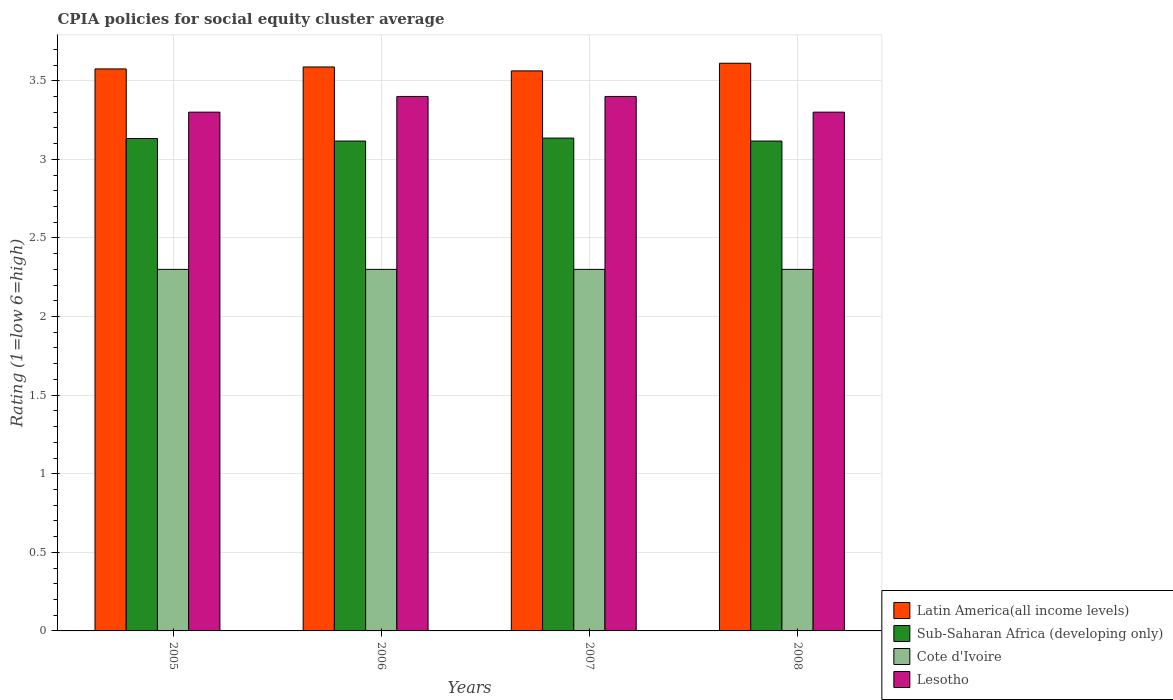How many groups of bars are there?
Offer a terse response. 4. Are the number of bars per tick equal to the number of legend labels?
Keep it short and to the point. Yes. What is the CPIA rating in Sub-Saharan Africa (developing only) in 2006?
Provide a succinct answer. 3.12. Across all years, what is the maximum CPIA rating in Sub-Saharan Africa (developing only)?
Give a very brief answer. 3.14. Across all years, what is the minimum CPIA rating in Lesotho?
Make the answer very short. 3.3. In which year was the CPIA rating in Sub-Saharan Africa (developing only) maximum?
Give a very brief answer. 2007. In which year was the CPIA rating in Sub-Saharan Africa (developing only) minimum?
Give a very brief answer. 2006. What is the total CPIA rating in Sub-Saharan Africa (developing only) in the graph?
Provide a short and direct response. 12.5. What is the difference between the CPIA rating in Sub-Saharan Africa (developing only) in 2006 and that in 2008?
Offer a terse response. 0. What is the difference between the CPIA rating in Sub-Saharan Africa (developing only) in 2007 and the CPIA rating in Lesotho in 2005?
Provide a short and direct response. -0.16. What is the average CPIA rating in Lesotho per year?
Give a very brief answer. 3.35. In the year 2008, what is the difference between the CPIA rating in Cote d'Ivoire and CPIA rating in Latin America(all income levels)?
Ensure brevity in your answer.  -1.31. What is the ratio of the CPIA rating in Cote d'Ivoire in 2005 to that in 2007?
Keep it short and to the point. 1. Is the difference between the CPIA rating in Cote d'Ivoire in 2007 and 2008 greater than the difference between the CPIA rating in Latin America(all income levels) in 2007 and 2008?
Provide a succinct answer. Yes. What is the difference between the highest and the second highest CPIA rating in Latin America(all income levels)?
Offer a terse response. 0.02. What is the difference between the highest and the lowest CPIA rating in Cote d'Ivoire?
Ensure brevity in your answer.  0. In how many years, is the CPIA rating in Cote d'Ivoire greater than the average CPIA rating in Cote d'Ivoire taken over all years?
Provide a succinct answer. 0. What does the 1st bar from the left in 2007 represents?
Your answer should be very brief. Latin America(all income levels). What does the 4th bar from the right in 2005 represents?
Provide a succinct answer. Latin America(all income levels). How many bars are there?
Your answer should be very brief. 16. How many years are there in the graph?
Provide a succinct answer. 4. What is the difference between two consecutive major ticks on the Y-axis?
Provide a short and direct response. 0.5. Does the graph contain any zero values?
Give a very brief answer. No. Does the graph contain grids?
Offer a very short reply. Yes. What is the title of the graph?
Provide a succinct answer. CPIA policies for social equity cluster average. Does "St. Vincent and the Grenadines" appear as one of the legend labels in the graph?
Keep it short and to the point. No. What is the label or title of the X-axis?
Offer a very short reply. Years. What is the label or title of the Y-axis?
Offer a very short reply. Rating (1=low 6=high). What is the Rating (1=low 6=high) of Latin America(all income levels) in 2005?
Your answer should be very brief. 3.58. What is the Rating (1=low 6=high) of Sub-Saharan Africa (developing only) in 2005?
Keep it short and to the point. 3.13. What is the Rating (1=low 6=high) in Latin America(all income levels) in 2006?
Your response must be concise. 3.59. What is the Rating (1=low 6=high) of Sub-Saharan Africa (developing only) in 2006?
Offer a terse response. 3.12. What is the Rating (1=low 6=high) of Latin America(all income levels) in 2007?
Your answer should be very brief. 3.56. What is the Rating (1=low 6=high) of Sub-Saharan Africa (developing only) in 2007?
Make the answer very short. 3.14. What is the Rating (1=low 6=high) in Cote d'Ivoire in 2007?
Your answer should be compact. 2.3. What is the Rating (1=low 6=high) of Latin America(all income levels) in 2008?
Provide a succinct answer. 3.61. What is the Rating (1=low 6=high) of Sub-Saharan Africa (developing only) in 2008?
Provide a short and direct response. 3.12. What is the Rating (1=low 6=high) of Lesotho in 2008?
Keep it short and to the point. 3.3. Across all years, what is the maximum Rating (1=low 6=high) in Latin America(all income levels)?
Your answer should be very brief. 3.61. Across all years, what is the maximum Rating (1=low 6=high) in Sub-Saharan Africa (developing only)?
Keep it short and to the point. 3.14. Across all years, what is the maximum Rating (1=low 6=high) of Cote d'Ivoire?
Keep it short and to the point. 2.3. Across all years, what is the minimum Rating (1=low 6=high) of Latin America(all income levels)?
Provide a short and direct response. 3.56. Across all years, what is the minimum Rating (1=low 6=high) in Sub-Saharan Africa (developing only)?
Ensure brevity in your answer.  3.12. Across all years, what is the minimum Rating (1=low 6=high) of Cote d'Ivoire?
Your answer should be compact. 2.3. Across all years, what is the minimum Rating (1=low 6=high) in Lesotho?
Give a very brief answer. 3.3. What is the total Rating (1=low 6=high) in Latin America(all income levels) in the graph?
Your response must be concise. 14.34. What is the total Rating (1=low 6=high) in Sub-Saharan Africa (developing only) in the graph?
Your answer should be very brief. 12.5. What is the total Rating (1=low 6=high) of Lesotho in the graph?
Provide a succinct answer. 13.4. What is the difference between the Rating (1=low 6=high) in Latin America(all income levels) in 2005 and that in 2006?
Ensure brevity in your answer.  -0.01. What is the difference between the Rating (1=low 6=high) of Sub-Saharan Africa (developing only) in 2005 and that in 2006?
Provide a short and direct response. 0.02. What is the difference between the Rating (1=low 6=high) in Cote d'Ivoire in 2005 and that in 2006?
Your answer should be compact. 0. What is the difference between the Rating (1=low 6=high) of Latin America(all income levels) in 2005 and that in 2007?
Provide a short and direct response. 0.01. What is the difference between the Rating (1=low 6=high) of Sub-Saharan Africa (developing only) in 2005 and that in 2007?
Provide a short and direct response. -0. What is the difference between the Rating (1=low 6=high) of Cote d'Ivoire in 2005 and that in 2007?
Make the answer very short. 0. What is the difference between the Rating (1=low 6=high) of Latin America(all income levels) in 2005 and that in 2008?
Ensure brevity in your answer.  -0.04. What is the difference between the Rating (1=low 6=high) in Sub-Saharan Africa (developing only) in 2005 and that in 2008?
Keep it short and to the point. 0.02. What is the difference between the Rating (1=low 6=high) in Cote d'Ivoire in 2005 and that in 2008?
Your answer should be very brief. 0. What is the difference between the Rating (1=low 6=high) in Latin America(all income levels) in 2006 and that in 2007?
Your answer should be compact. 0.03. What is the difference between the Rating (1=low 6=high) in Sub-Saharan Africa (developing only) in 2006 and that in 2007?
Your answer should be very brief. -0.02. What is the difference between the Rating (1=low 6=high) of Latin America(all income levels) in 2006 and that in 2008?
Your response must be concise. -0.02. What is the difference between the Rating (1=low 6=high) of Lesotho in 2006 and that in 2008?
Provide a succinct answer. 0.1. What is the difference between the Rating (1=low 6=high) of Latin America(all income levels) in 2007 and that in 2008?
Offer a terse response. -0.05. What is the difference between the Rating (1=low 6=high) of Sub-Saharan Africa (developing only) in 2007 and that in 2008?
Offer a very short reply. 0.02. What is the difference between the Rating (1=low 6=high) of Latin America(all income levels) in 2005 and the Rating (1=low 6=high) of Sub-Saharan Africa (developing only) in 2006?
Offer a very short reply. 0.46. What is the difference between the Rating (1=low 6=high) of Latin America(all income levels) in 2005 and the Rating (1=low 6=high) of Cote d'Ivoire in 2006?
Provide a succinct answer. 1.27. What is the difference between the Rating (1=low 6=high) of Latin America(all income levels) in 2005 and the Rating (1=low 6=high) of Lesotho in 2006?
Offer a very short reply. 0.17. What is the difference between the Rating (1=low 6=high) in Sub-Saharan Africa (developing only) in 2005 and the Rating (1=low 6=high) in Cote d'Ivoire in 2006?
Offer a very short reply. 0.83. What is the difference between the Rating (1=low 6=high) in Sub-Saharan Africa (developing only) in 2005 and the Rating (1=low 6=high) in Lesotho in 2006?
Make the answer very short. -0.27. What is the difference between the Rating (1=low 6=high) of Latin America(all income levels) in 2005 and the Rating (1=low 6=high) of Sub-Saharan Africa (developing only) in 2007?
Your answer should be compact. 0.44. What is the difference between the Rating (1=low 6=high) in Latin America(all income levels) in 2005 and the Rating (1=low 6=high) in Cote d'Ivoire in 2007?
Your answer should be very brief. 1.27. What is the difference between the Rating (1=low 6=high) in Latin America(all income levels) in 2005 and the Rating (1=low 6=high) in Lesotho in 2007?
Offer a terse response. 0.17. What is the difference between the Rating (1=low 6=high) of Sub-Saharan Africa (developing only) in 2005 and the Rating (1=low 6=high) of Cote d'Ivoire in 2007?
Keep it short and to the point. 0.83. What is the difference between the Rating (1=low 6=high) of Sub-Saharan Africa (developing only) in 2005 and the Rating (1=low 6=high) of Lesotho in 2007?
Your answer should be very brief. -0.27. What is the difference between the Rating (1=low 6=high) of Latin America(all income levels) in 2005 and the Rating (1=low 6=high) of Sub-Saharan Africa (developing only) in 2008?
Provide a succinct answer. 0.46. What is the difference between the Rating (1=low 6=high) of Latin America(all income levels) in 2005 and the Rating (1=low 6=high) of Cote d'Ivoire in 2008?
Ensure brevity in your answer.  1.27. What is the difference between the Rating (1=low 6=high) of Latin America(all income levels) in 2005 and the Rating (1=low 6=high) of Lesotho in 2008?
Give a very brief answer. 0.28. What is the difference between the Rating (1=low 6=high) of Sub-Saharan Africa (developing only) in 2005 and the Rating (1=low 6=high) of Cote d'Ivoire in 2008?
Offer a terse response. 0.83. What is the difference between the Rating (1=low 6=high) in Sub-Saharan Africa (developing only) in 2005 and the Rating (1=low 6=high) in Lesotho in 2008?
Provide a succinct answer. -0.17. What is the difference between the Rating (1=low 6=high) in Latin America(all income levels) in 2006 and the Rating (1=low 6=high) in Sub-Saharan Africa (developing only) in 2007?
Offer a terse response. 0.45. What is the difference between the Rating (1=low 6=high) of Latin America(all income levels) in 2006 and the Rating (1=low 6=high) of Cote d'Ivoire in 2007?
Your response must be concise. 1.29. What is the difference between the Rating (1=low 6=high) of Latin America(all income levels) in 2006 and the Rating (1=low 6=high) of Lesotho in 2007?
Provide a succinct answer. 0.19. What is the difference between the Rating (1=low 6=high) in Sub-Saharan Africa (developing only) in 2006 and the Rating (1=low 6=high) in Cote d'Ivoire in 2007?
Provide a succinct answer. 0.82. What is the difference between the Rating (1=low 6=high) in Sub-Saharan Africa (developing only) in 2006 and the Rating (1=low 6=high) in Lesotho in 2007?
Provide a succinct answer. -0.28. What is the difference between the Rating (1=low 6=high) in Latin America(all income levels) in 2006 and the Rating (1=low 6=high) in Sub-Saharan Africa (developing only) in 2008?
Give a very brief answer. 0.47. What is the difference between the Rating (1=low 6=high) in Latin America(all income levels) in 2006 and the Rating (1=low 6=high) in Cote d'Ivoire in 2008?
Provide a succinct answer. 1.29. What is the difference between the Rating (1=low 6=high) in Latin America(all income levels) in 2006 and the Rating (1=low 6=high) in Lesotho in 2008?
Provide a short and direct response. 0.29. What is the difference between the Rating (1=low 6=high) of Sub-Saharan Africa (developing only) in 2006 and the Rating (1=low 6=high) of Cote d'Ivoire in 2008?
Offer a terse response. 0.82. What is the difference between the Rating (1=low 6=high) of Sub-Saharan Africa (developing only) in 2006 and the Rating (1=low 6=high) of Lesotho in 2008?
Offer a terse response. -0.18. What is the difference between the Rating (1=low 6=high) of Cote d'Ivoire in 2006 and the Rating (1=low 6=high) of Lesotho in 2008?
Provide a succinct answer. -1. What is the difference between the Rating (1=low 6=high) of Latin America(all income levels) in 2007 and the Rating (1=low 6=high) of Sub-Saharan Africa (developing only) in 2008?
Your response must be concise. 0.45. What is the difference between the Rating (1=low 6=high) in Latin America(all income levels) in 2007 and the Rating (1=low 6=high) in Cote d'Ivoire in 2008?
Provide a short and direct response. 1.26. What is the difference between the Rating (1=low 6=high) of Latin America(all income levels) in 2007 and the Rating (1=low 6=high) of Lesotho in 2008?
Provide a succinct answer. 0.26. What is the difference between the Rating (1=low 6=high) in Sub-Saharan Africa (developing only) in 2007 and the Rating (1=low 6=high) in Cote d'Ivoire in 2008?
Your answer should be very brief. 0.84. What is the difference between the Rating (1=low 6=high) of Sub-Saharan Africa (developing only) in 2007 and the Rating (1=low 6=high) of Lesotho in 2008?
Keep it short and to the point. -0.16. What is the average Rating (1=low 6=high) in Latin America(all income levels) per year?
Your answer should be compact. 3.58. What is the average Rating (1=low 6=high) of Sub-Saharan Africa (developing only) per year?
Provide a succinct answer. 3.12. What is the average Rating (1=low 6=high) of Cote d'Ivoire per year?
Offer a terse response. 2.3. What is the average Rating (1=low 6=high) in Lesotho per year?
Make the answer very short. 3.35. In the year 2005, what is the difference between the Rating (1=low 6=high) of Latin America(all income levels) and Rating (1=low 6=high) of Sub-Saharan Africa (developing only)?
Give a very brief answer. 0.44. In the year 2005, what is the difference between the Rating (1=low 6=high) of Latin America(all income levels) and Rating (1=low 6=high) of Cote d'Ivoire?
Keep it short and to the point. 1.27. In the year 2005, what is the difference between the Rating (1=low 6=high) in Latin America(all income levels) and Rating (1=low 6=high) in Lesotho?
Your answer should be compact. 0.28. In the year 2005, what is the difference between the Rating (1=low 6=high) of Sub-Saharan Africa (developing only) and Rating (1=low 6=high) of Cote d'Ivoire?
Your answer should be very brief. 0.83. In the year 2005, what is the difference between the Rating (1=low 6=high) of Sub-Saharan Africa (developing only) and Rating (1=low 6=high) of Lesotho?
Provide a succinct answer. -0.17. In the year 2005, what is the difference between the Rating (1=low 6=high) of Cote d'Ivoire and Rating (1=low 6=high) of Lesotho?
Your answer should be very brief. -1. In the year 2006, what is the difference between the Rating (1=low 6=high) of Latin America(all income levels) and Rating (1=low 6=high) of Sub-Saharan Africa (developing only)?
Your response must be concise. 0.47. In the year 2006, what is the difference between the Rating (1=low 6=high) in Latin America(all income levels) and Rating (1=low 6=high) in Cote d'Ivoire?
Make the answer very short. 1.29. In the year 2006, what is the difference between the Rating (1=low 6=high) of Latin America(all income levels) and Rating (1=low 6=high) of Lesotho?
Keep it short and to the point. 0.19. In the year 2006, what is the difference between the Rating (1=low 6=high) of Sub-Saharan Africa (developing only) and Rating (1=low 6=high) of Cote d'Ivoire?
Your answer should be very brief. 0.82. In the year 2006, what is the difference between the Rating (1=low 6=high) in Sub-Saharan Africa (developing only) and Rating (1=low 6=high) in Lesotho?
Keep it short and to the point. -0.28. In the year 2006, what is the difference between the Rating (1=low 6=high) in Cote d'Ivoire and Rating (1=low 6=high) in Lesotho?
Your answer should be compact. -1.1. In the year 2007, what is the difference between the Rating (1=low 6=high) in Latin America(all income levels) and Rating (1=low 6=high) in Sub-Saharan Africa (developing only)?
Keep it short and to the point. 0.43. In the year 2007, what is the difference between the Rating (1=low 6=high) of Latin America(all income levels) and Rating (1=low 6=high) of Cote d'Ivoire?
Offer a very short reply. 1.26. In the year 2007, what is the difference between the Rating (1=low 6=high) of Latin America(all income levels) and Rating (1=low 6=high) of Lesotho?
Your response must be concise. 0.16. In the year 2007, what is the difference between the Rating (1=low 6=high) in Sub-Saharan Africa (developing only) and Rating (1=low 6=high) in Cote d'Ivoire?
Your answer should be compact. 0.84. In the year 2007, what is the difference between the Rating (1=low 6=high) of Sub-Saharan Africa (developing only) and Rating (1=low 6=high) of Lesotho?
Ensure brevity in your answer.  -0.26. In the year 2007, what is the difference between the Rating (1=low 6=high) in Cote d'Ivoire and Rating (1=low 6=high) in Lesotho?
Provide a succinct answer. -1.1. In the year 2008, what is the difference between the Rating (1=low 6=high) in Latin America(all income levels) and Rating (1=low 6=high) in Sub-Saharan Africa (developing only)?
Your response must be concise. 0.49. In the year 2008, what is the difference between the Rating (1=low 6=high) of Latin America(all income levels) and Rating (1=low 6=high) of Cote d'Ivoire?
Your answer should be very brief. 1.31. In the year 2008, what is the difference between the Rating (1=low 6=high) of Latin America(all income levels) and Rating (1=low 6=high) of Lesotho?
Offer a terse response. 0.31. In the year 2008, what is the difference between the Rating (1=low 6=high) in Sub-Saharan Africa (developing only) and Rating (1=low 6=high) in Cote d'Ivoire?
Your answer should be very brief. 0.82. In the year 2008, what is the difference between the Rating (1=low 6=high) of Sub-Saharan Africa (developing only) and Rating (1=low 6=high) of Lesotho?
Give a very brief answer. -0.18. In the year 2008, what is the difference between the Rating (1=low 6=high) in Cote d'Ivoire and Rating (1=low 6=high) in Lesotho?
Your answer should be compact. -1. What is the ratio of the Rating (1=low 6=high) of Sub-Saharan Africa (developing only) in 2005 to that in 2006?
Provide a short and direct response. 1.01. What is the ratio of the Rating (1=low 6=high) in Cote d'Ivoire in 2005 to that in 2006?
Make the answer very short. 1. What is the ratio of the Rating (1=low 6=high) of Lesotho in 2005 to that in 2006?
Your answer should be very brief. 0.97. What is the ratio of the Rating (1=low 6=high) of Latin America(all income levels) in 2005 to that in 2007?
Make the answer very short. 1. What is the ratio of the Rating (1=low 6=high) in Sub-Saharan Africa (developing only) in 2005 to that in 2007?
Give a very brief answer. 1. What is the ratio of the Rating (1=low 6=high) of Cote d'Ivoire in 2005 to that in 2007?
Make the answer very short. 1. What is the ratio of the Rating (1=low 6=high) in Lesotho in 2005 to that in 2007?
Give a very brief answer. 0.97. What is the ratio of the Rating (1=low 6=high) in Latin America(all income levels) in 2005 to that in 2008?
Ensure brevity in your answer.  0.99. What is the ratio of the Rating (1=low 6=high) of Sub-Saharan Africa (developing only) in 2005 to that in 2008?
Offer a terse response. 1.01. What is the ratio of the Rating (1=low 6=high) of Cote d'Ivoire in 2005 to that in 2008?
Provide a succinct answer. 1. What is the ratio of the Rating (1=low 6=high) in Lesotho in 2005 to that in 2008?
Your answer should be very brief. 1. What is the ratio of the Rating (1=low 6=high) of Sub-Saharan Africa (developing only) in 2006 to that in 2007?
Offer a terse response. 0.99. What is the ratio of the Rating (1=low 6=high) in Lesotho in 2006 to that in 2007?
Give a very brief answer. 1. What is the ratio of the Rating (1=low 6=high) in Latin America(all income levels) in 2006 to that in 2008?
Ensure brevity in your answer.  0.99. What is the ratio of the Rating (1=low 6=high) in Sub-Saharan Africa (developing only) in 2006 to that in 2008?
Provide a short and direct response. 1. What is the ratio of the Rating (1=low 6=high) in Cote d'Ivoire in 2006 to that in 2008?
Give a very brief answer. 1. What is the ratio of the Rating (1=low 6=high) of Lesotho in 2006 to that in 2008?
Your response must be concise. 1.03. What is the ratio of the Rating (1=low 6=high) in Latin America(all income levels) in 2007 to that in 2008?
Make the answer very short. 0.99. What is the ratio of the Rating (1=low 6=high) of Cote d'Ivoire in 2007 to that in 2008?
Your answer should be compact. 1. What is the ratio of the Rating (1=low 6=high) in Lesotho in 2007 to that in 2008?
Offer a terse response. 1.03. What is the difference between the highest and the second highest Rating (1=low 6=high) in Latin America(all income levels)?
Your response must be concise. 0.02. What is the difference between the highest and the second highest Rating (1=low 6=high) of Sub-Saharan Africa (developing only)?
Ensure brevity in your answer.  0. What is the difference between the highest and the second highest Rating (1=low 6=high) of Cote d'Ivoire?
Provide a short and direct response. 0. What is the difference between the highest and the second highest Rating (1=low 6=high) in Lesotho?
Offer a very short reply. 0. What is the difference between the highest and the lowest Rating (1=low 6=high) in Latin America(all income levels)?
Offer a terse response. 0.05. What is the difference between the highest and the lowest Rating (1=low 6=high) in Sub-Saharan Africa (developing only)?
Your answer should be very brief. 0.02. What is the difference between the highest and the lowest Rating (1=low 6=high) in Cote d'Ivoire?
Offer a terse response. 0. What is the difference between the highest and the lowest Rating (1=low 6=high) in Lesotho?
Give a very brief answer. 0.1. 